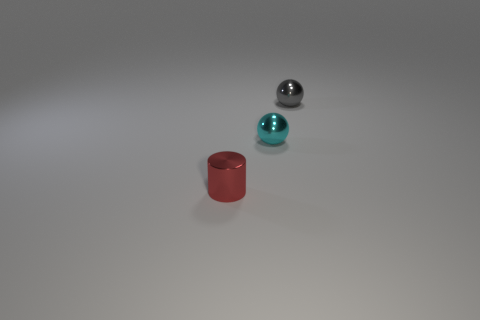Add 2 tiny red objects. How many objects exist? 5 Subtract 2 spheres. How many spheres are left? 0 Add 1 yellow cylinders. How many yellow cylinders exist? 1 Subtract all cyan spheres. How many spheres are left? 1 Subtract 0 yellow cubes. How many objects are left? 3 Subtract all cylinders. How many objects are left? 2 Subtract all brown balls. Subtract all brown cubes. How many balls are left? 2 Subtract all brown cylinders. How many cyan balls are left? 1 Subtract all gray metal spheres. Subtract all cyan spheres. How many objects are left? 1 Add 1 gray balls. How many gray balls are left? 2 